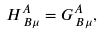Convert formula to latex. <formula><loc_0><loc_0><loc_500><loc_500>H ^ { A } _ { \, B \mu } = G ^ { A } _ { \, B \mu } ,</formula> 